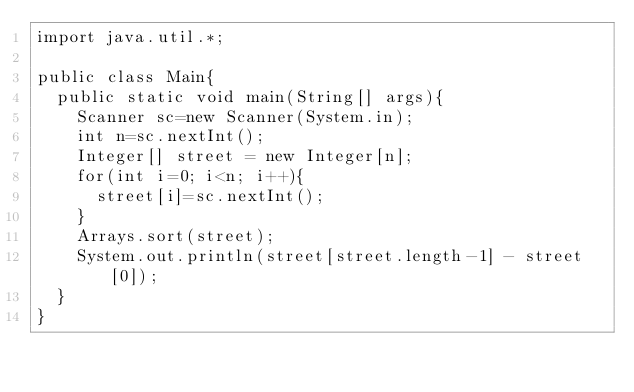Convert code to text. <code><loc_0><loc_0><loc_500><loc_500><_Java_>import java.util.*;

public class Main{
  public static void main(String[] args){
    Scanner sc=new Scanner(System.in);
    int n=sc.nextInt();
    Integer[] street = new Integer[n];
    for(int i=0; i<n; i++){
      street[i]=sc.nextInt();
    }
    Arrays.sort(street);
    System.out.println(street[street.length-1] - street[0]);
  }
}</code> 